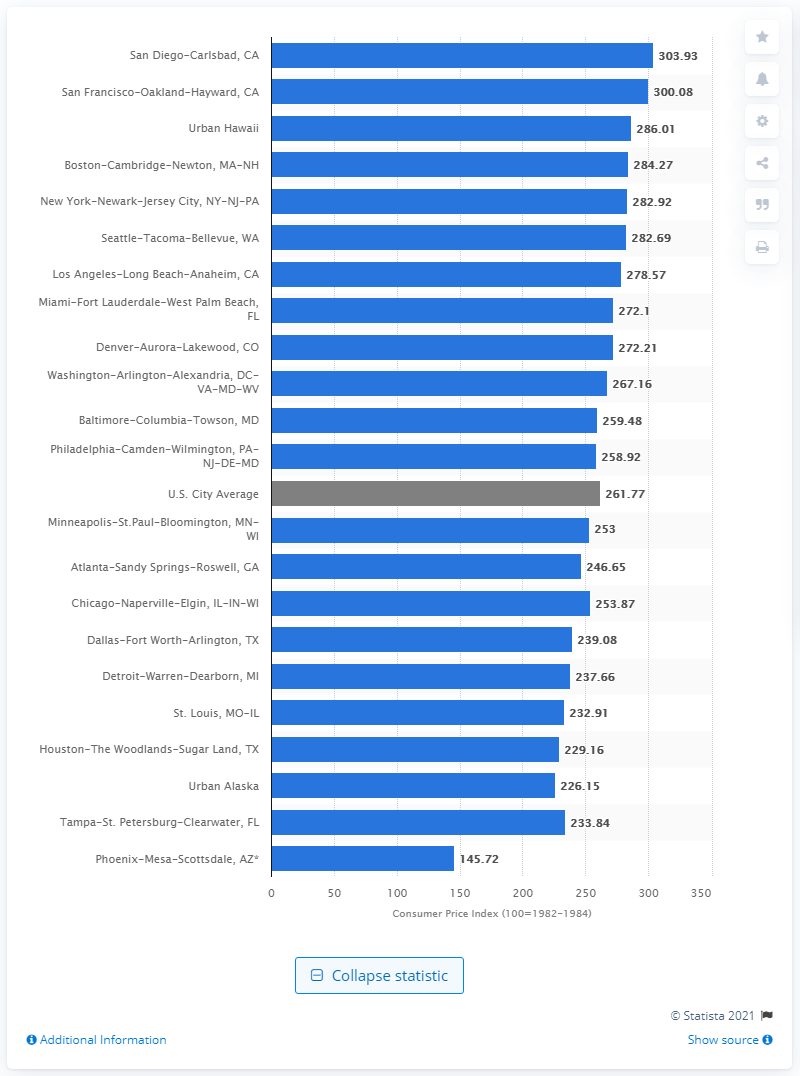Point out several critical features in this image. In 2020, the Consumer Price Index (CPI) for the New York-Newark-Jersey City metropolitan area was 282.92. According to data from 2020, the Consumer Price Index (CPI) in cities across the United States was 261.77. 